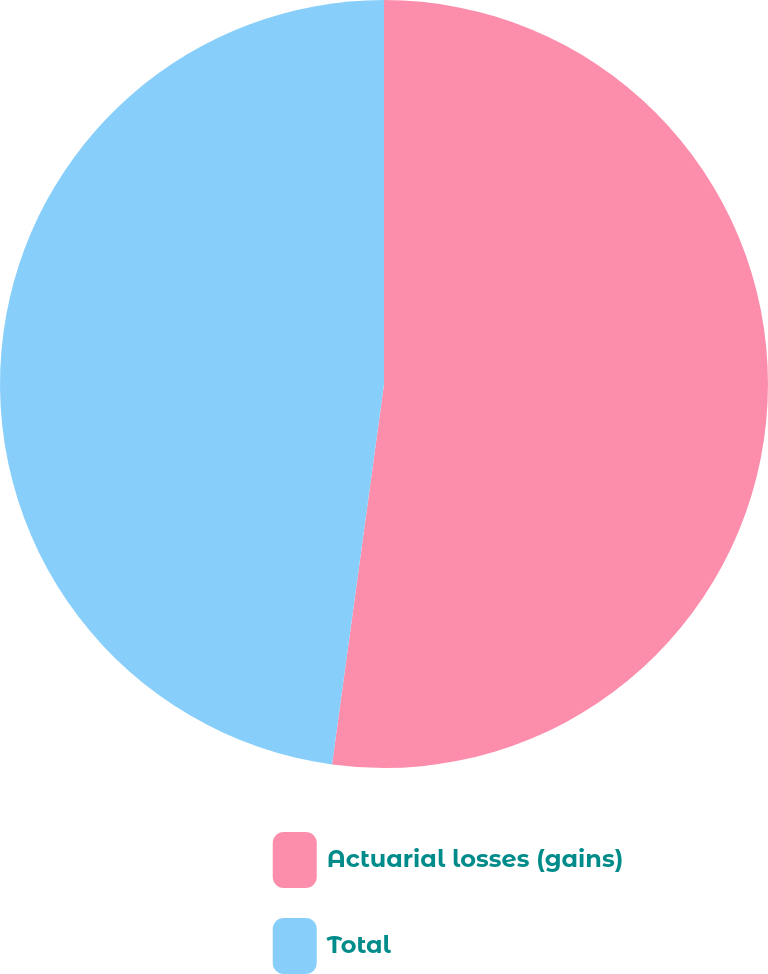Convert chart to OTSL. <chart><loc_0><loc_0><loc_500><loc_500><pie_chart><fcel>Actuarial losses (gains)<fcel>Total<nl><fcel>52.16%<fcel>47.84%<nl></chart> 